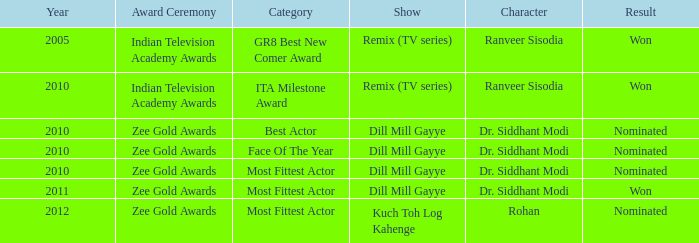Which character was nominated in the 2010 indian television academy awards? Ranveer Sisodia. 